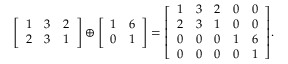<formula> <loc_0><loc_0><loc_500><loc_500>{ \left [ \begin{array} { l l l } { 1 } & { 3 } & { 2 } \\ { 2 } & { 3 } & { 1 } \end{array} \right ] } \oplus { \left [ \begin{array} { l l } { 1 } & { 6 } \\ { 0 } & { 1 } \end{array} \right ] } = { \left [ \begin{array} { l l l l l } { 1 } & { 3 } & { 2 } & { 0 } & { 0 } \\ { 2 } & { 3 } & { 1 } & { 0 } & { 0 } \\ { 0 } & { 0 } & { 0 } & { 1 } & { 6 } \\ { 0 } & { 0 } & { 0 } & { 0 } & { 1 } \end{array} \right ] } .</formula> 